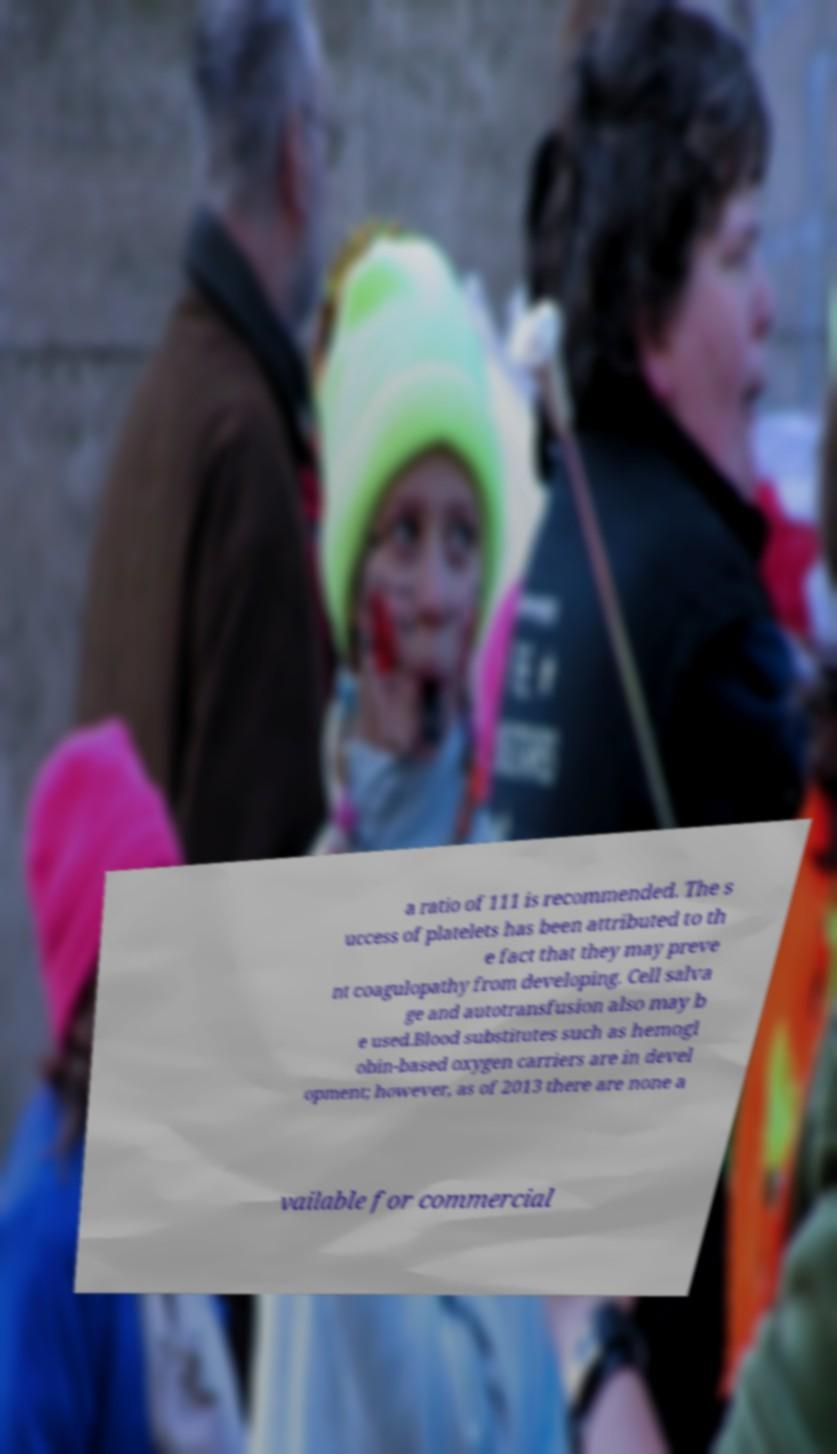Please read and relay the text visible in this image. What does it say? a ratio of 111 is recommended. The s uccess of platelets has been attributed to th e fact that they may preve nt coagulopathy from developing. Cell salva ge and autotransfusion also may b e used.Blood substitutes such as hemogl obin-based oxygen carriers are in devel opment; however, as of 2013 there are none a vailable for commercial 